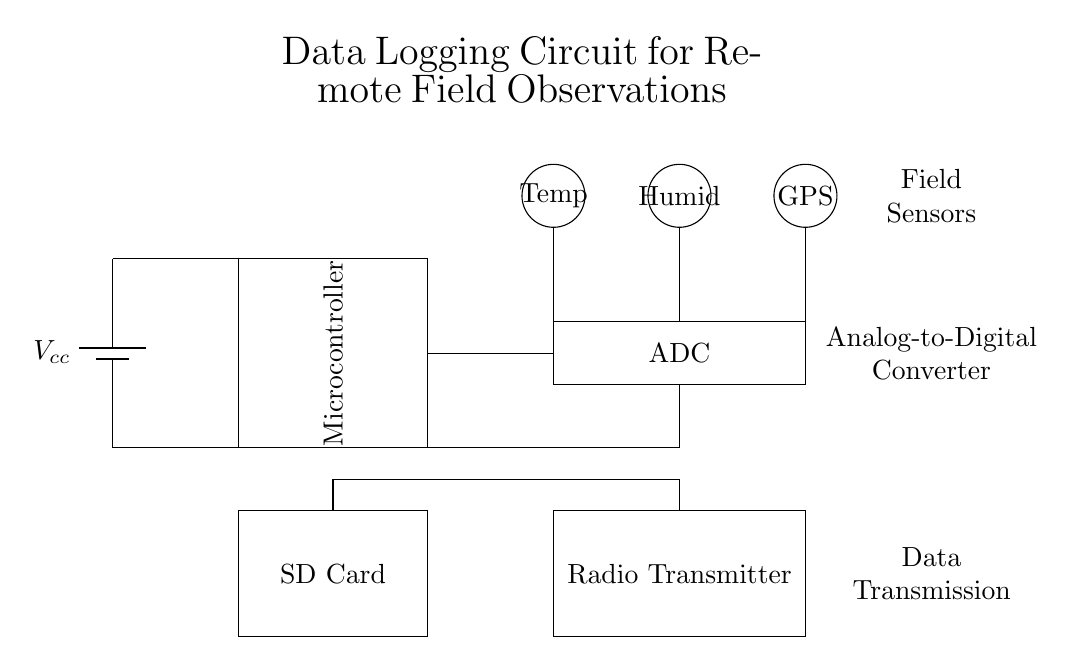What is the power supply in the circuit? The circuit uses a battery as the power supply, which is indicated at the top left corner of the diagram.
Answer: Battery What does the Microcontroller do in this circuit? The Microcontroller processes the data collected from the sensors before storing or transmitting it. It is represented by the rectangular component labeled "Microcontroller" in the middle of the circuit.
Answer: Data processing How many sensors are connected to the circuit? There are three sensors connected, as seen in the upper section of the diagram labeled with "Temp," "Humid," and "GPS."
Answer: Three What is the function of the ADC in this circuit? The ADC, or Analog-to-Digital Converter, digitizes the analog signals from the sensors for the microcontroller to process. It is located below the sensors in the circuit.
Answer: Digitization Where do the sensor outputs go in the circuit? The outputs from the sensors terminate at the ADC, indicated by the connections from the sensors to the rectangular shape labeled "ADC."
Answer: To the ADC What is the purpose of the Radio Transmitter? The Radio Transmitter sends out the processed data wirelessly, and it is represented at the bottom right of the diagram.
Answer: Data transmission Which component stores the data in this circuit? The SD Card component is responsible for data storage, as shown in the lower section of the circuit labeled "SD Card."
Answer: SD Card 